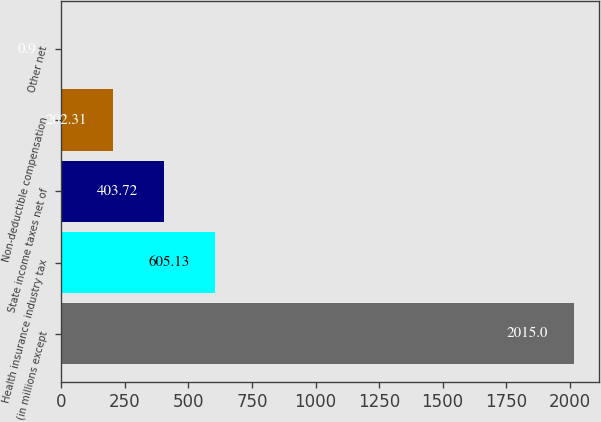Convert chart. <chart><loc_0><loc_0><loc_500><loc_500><bar_chart><fcel>(in millions except<fcel>Health insurance industry tax<fcel>State income taxes net of<fcel>Non-deductible compensation<fcel>Other net<nl><fcel>2015<fcel>605.13<fcel>403.72<fcel>202.31<fcel>0.9<nl></chart> 